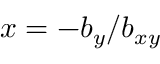Convert formula to latex. <formula><loc_0><loc_0><loc_500><loc_500>x = - b _ { y } / b _ { x y }</formula> 